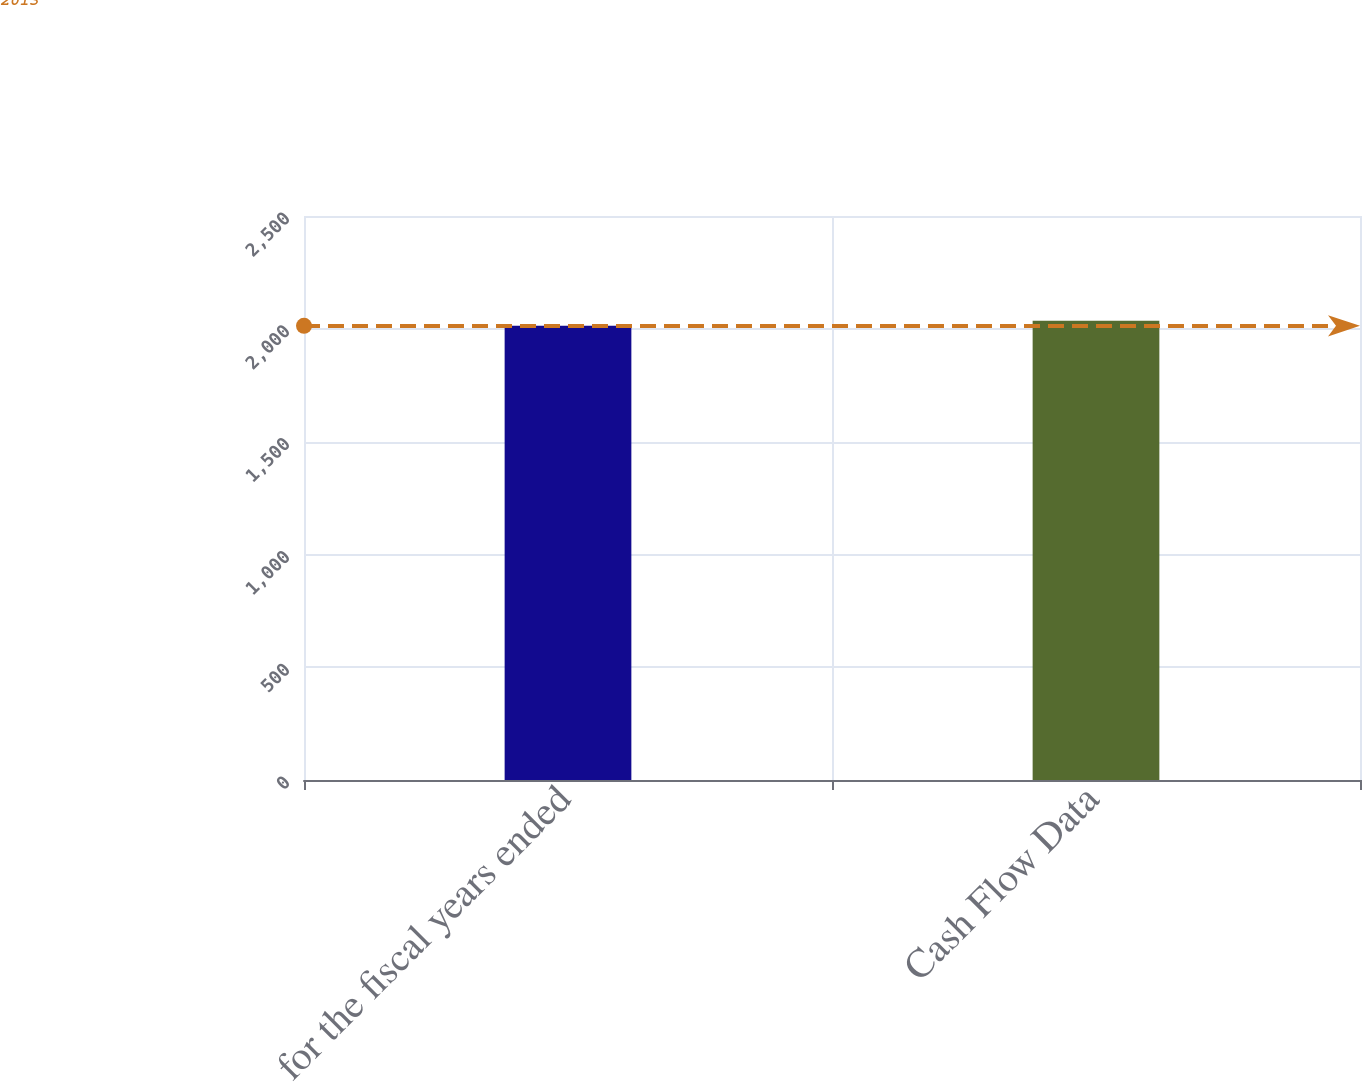Convert chart. <chart><loc_0><loc_0><loc_500><loc_500><bar_chart><fcel>for the fiscal years ended<fcel>Cash Flow Data<nl><fcel>2013<fcel>2035.7<nl></chart> 